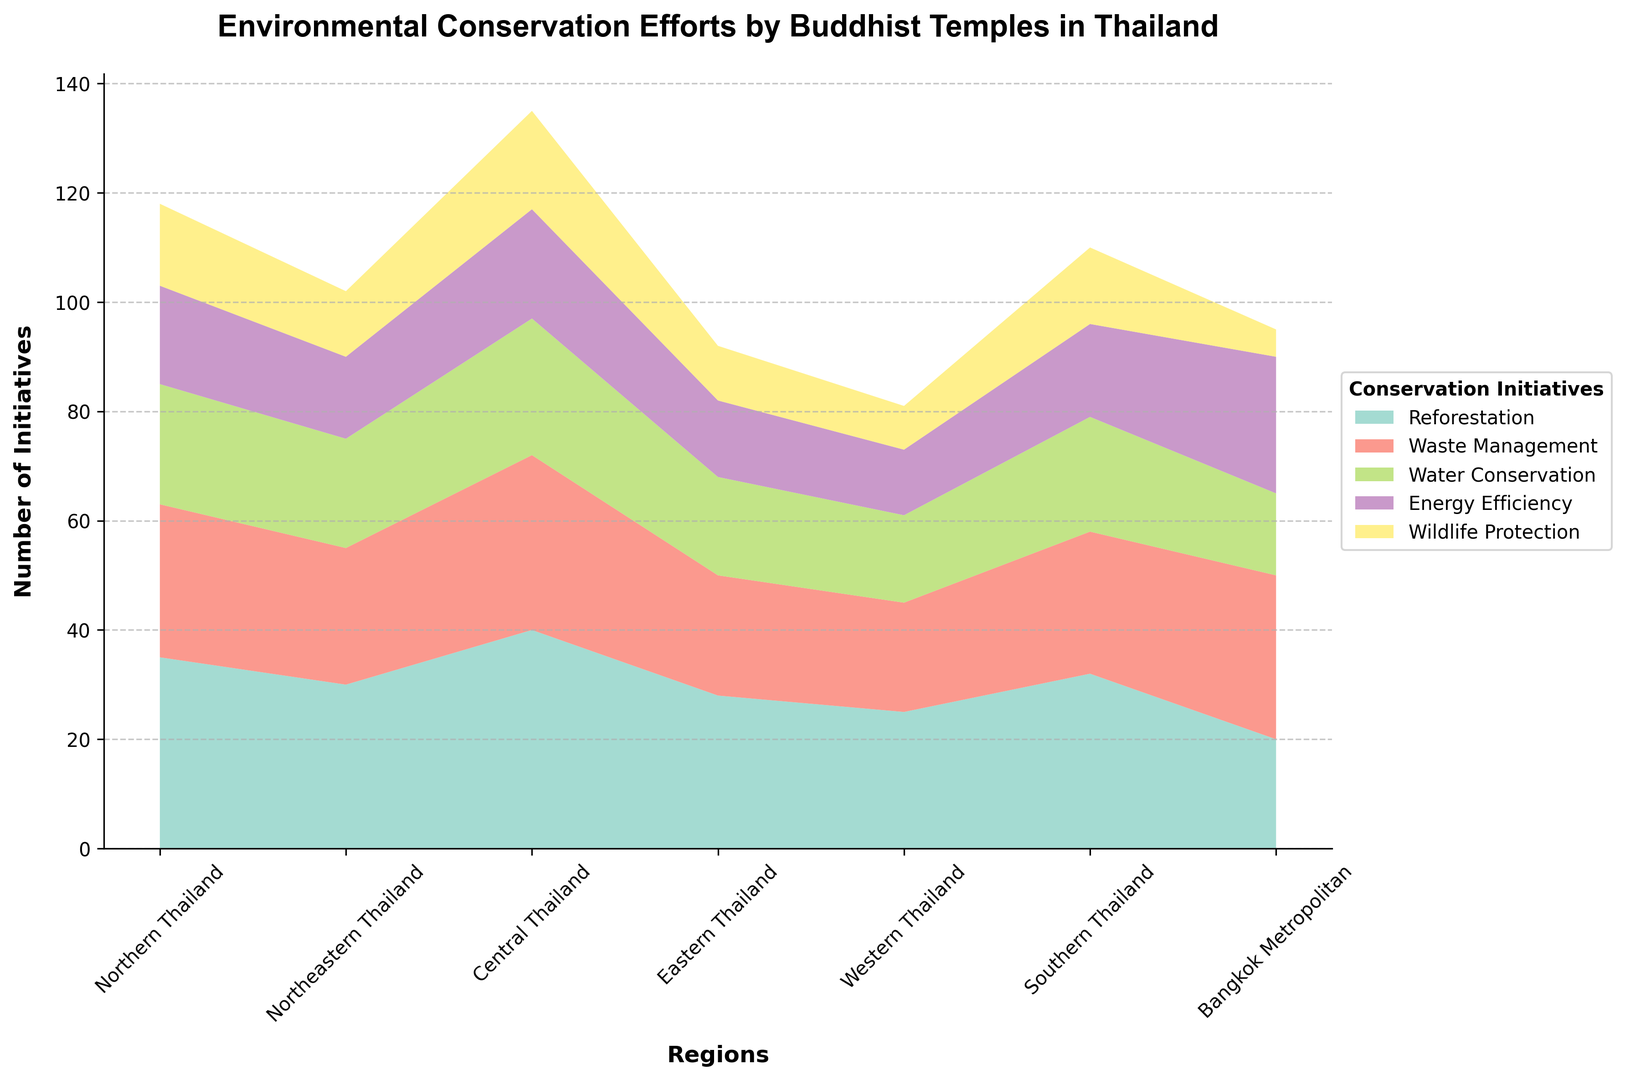How many total environmental conservation initiatives are implemented by the temples in Northern Thailand? Sum the values for each type of initiative in Northern Thailand: 35 (Reforestation) + 28 (Waste Management) + 22 (Water Conservation) + 18 (Energy Efficiency) + 15 (Wildlife Protection) = 118
Answer: 118 Which region has the highest number of energy efficiency initiatives? Compare the energy efficiency values across all regions. The highest value is 25 in Bangkok Metropolitan.
Answer: Bangkok Metropolitan What is the combined number of reforestation and wildlife protection initiatives in Southern Thailand? Add the values for reforestation and wildlife protection in Southern Thailand: 32 (Reforestation) + 14 (Wildlife Protection) = 46
Answer: 46 How does the waste management efforts in Bangkok Metropolitan compare to those in Central Thailand? Compare the waste management values for Bangkok Metropolitan (30) and Central Thailand (32). Bangkok Metropolitan has slightly fewer initiatives.
Answer: Slightly fewer in Bangkok Metropolitan In which region is the contribution to water conservation the lowest? Identify the region with the smallest value for water conservation. The smallest value is 15 in Bangkok Metropolitan.
Answer: Bangkok Metropolitan What is the difference in the number of wildlife protection initiatives between Eastern and Western Thailand? Subtract the number of wildlife protection initiatives in Western Thailand (8) from Eastern Thailand (10): 10 - 8 = 2
Answer: 2 Which type of initiative has the most significant number in Central Thailand? Identify the initiative with the highest value in Central Thailand. The highest value is 40 for Reforestation.
Answer: Reforestation What is the average number of energy efficiency initiatives across all regions? Sum the energy efficiency values: 18 + 15 + 20 + 14 + 12 + 17 + 25 = 121. Divide by the number of regions (7): 121 / 7 ≈ 17.29
Answer: 17.29 Which region shows the most balanced distribution of initiatives across different types? Visually inspect which region has uniform bars of similar height across initiatives. Northeastern Thailand shows a relatively balanced distribution.
Answer: Northeastern Thailand What overall trend can be seen regarding the prominence of reforestation initiatives by Buddhist temples in Thailand? Reforestation values are higher across most regions. It stands out as the most frequent initiative, especially reaching the highest value in Central Thailand (40).
Answer: Reforestation is most frequent 